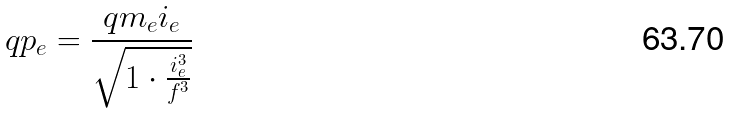<formula> <loc_0><loc_0><loc_500><loc_500>q p _ { e } = \frac { q m _ { e } i _ { e } } { \sqrt { 1 \cdot \frac { i _ { e } ^ { 3 } } { f ^ { 3 } } } }</formula> 